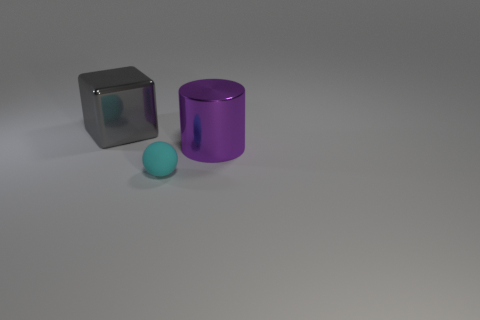Subtract all purple blocks. Subtract all brown spheres. How many blocks are left? 1 Add 1 large purple things. How many objects exist? 4 Subtract all spheres. How many objects are left? 2 Add 3 big gray shiny cubes. How many big gray shiny cubes are left? 4 Add 3 small green spheres. How many small green spheres exist? 3 Subtract 1 purple cylinders. How many objects are left? 2 Subtract all tiny rubber cubes. Subtract all purple things. How many objects are left? 2 